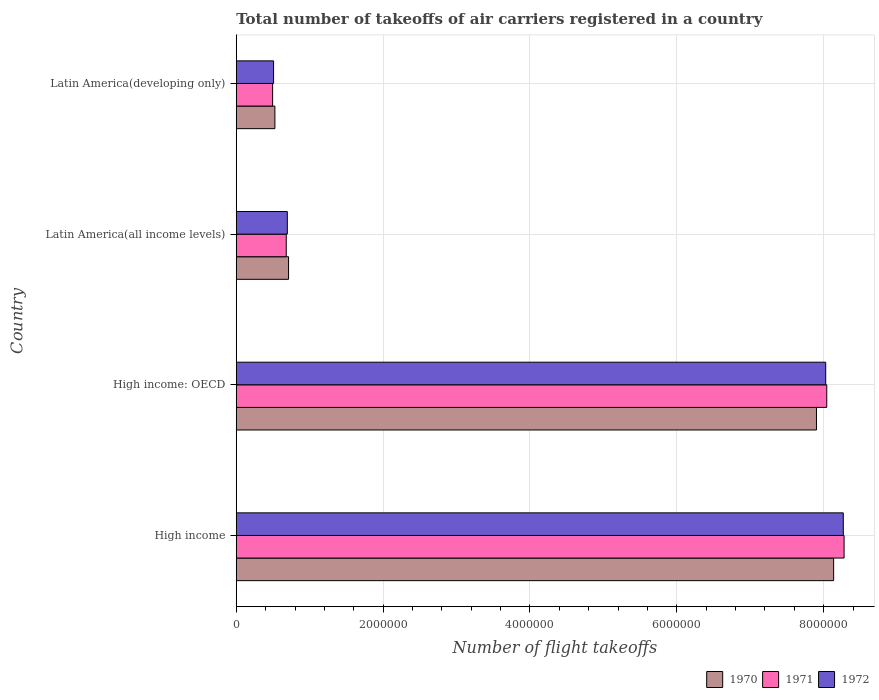How many different coloured bars are there?
Ensure brevity in your answer.  3. How many groups of bars are there?
Your response must be concise. 4. Are the number of bars per tick equal to the number of legend labels?
Provide a short and direct response. Yes. How many bars are there on the 1st tick from the top?
Give a very brief answer. 3. How many bars are there on the 1st tick from the bottom?
Offer a terse response. 3. What is the label of the 4th group of bars from the top?
Your response must be concise. High income. What is the total number of flight takeoffs in 1970 in Latin America(developing only)?
Your answer should be very brief. 5.26e+05. Across all countries, what is the maximum total number of flight takeoffs in 1971?
Offer a very short reply. 8.28e+06. Across all countries, what is the minimum total number of flight takeoffs in 1972?
Offer a very short reply. 5.08e+05. In which country was the total number of flight takeoffs in 1971 minimum?
Give a very brief answer. Latin America(developing only). What is the total total number of flight takeoffs in 1972 in the graph?
Provide a succinct answer. 1.75e+07. What is the difference between the total number of flight takeoffs in 1971 in High income and that in Latin America(all income levels)?
Give a very brief answer. 7.60e+06. What is the difference between the total number of flight takeoffs in 1970 in High income: OECD and the total number of flight takeoffs in 1971 in Latin America(all income levels)?
Make the answer very short. 7.22e+06. What is the average total number of flight takeoffs in 1972 per country?
Offer a terse response. 4.37e+06. What is the difference between the total number of flight takeoffs in 1972 and total number of flight takeoffs in 1970 in Latin America(developing only)?
Provide a succinct answer. -1.79e+04. In how many countries, is the total number of flight takeoffs in 1971 greater than 4800000 ?
Provide a short and direct response. 2. What is the ratio of the total number of flight takeoffs in 1970 in High income to that in Latin America(developing only)?
Provide a succinct answer. 15.46. What is the difference between the highest and the second highest total number of flight takeoffs in 1970?
Make the answer very short. 2.34e+05. What is the difference between the highest and the lowest total number of flight takeoffs in 1970?
Give a very brief answer. 7.61e+06. In how many countries, is the total number of flight takeoffs in 1972 greater than the average total number of flight takeoffs in 1972 taken over all countries?
Make the answer very short. 2. Is the sum of the total number of flight takeoffs in 1972 in High income and Latin America(developing only) greater than the maximum total number of flight takeoffs in 1970 across all countries?
Your answer should be very brief. Yes. What does the 3rd bar from the bottom in Latin America(all income levels) represents?
Provide a succinct answer. 1972. Is it the case that in every country, the sum of the total number of flight takeoffs in 1972 and total number of flight takeoffs in 1970 is greater than the total number of flight takeoffs in 1971?
Your answer should be compact. Yes. How many bars are there?
Keep it short and to the point. 12. What is the difference between two consecutive major ticks on the X-axis?
Keep it short and to the point. 2.00e+06. Are the values on the major ticks of X-axis written in scientific E-notation?
Your answer should be compact. No. Does the graph contain any zero values?
Your answer should be compact. No. Does the graph contain grids?
Provide a succinct answer. Yes. How are the legend labels stacked?
Offer a terse response. Horizontal. What is the title of the graph?
Your answer should be very brief. Total number of takeoffs of air carriers registered in a country. Does "2007" appear as one of the legend labels in the graph?
Give a very brief answer. No. What is the label or title of the X-axis?
Your answer should be very brief. Number of flight takeoffs. What is the label or title of the Y-axis?
Offer a terse response. Country. What is the Number of flight takeoffs in 1970 in High income?
Provide a succinct answer. 8.14e+06. What is the Number of flight takeoffs in 1971 in High income?
Keep it short and to the point. 8.28e+06. What is the Number of flight takeoffs of 1972 in High income?
Your answer should be very brief. 8.27e+06. What is the Number of flight takeoffs in 1970 in High income: OECD?
Your answer should be compact. 7.90e+06. What is the Number of flight takeoffs of 1971 in High income: OECD?
Your answer should be very brief. 8.04e+06. What is the Number of flight takeoffs in 1972 in High income: OECD?
Provide a short and direct response. 8.03e+06. What is the Number of flight takeoffs of 1970 in Latin America(all income levels)?
Provide a short and direct response. 7.12e+05. What is the Number of flight takeoffs in 1971 in Latin America(all income levels)?
Make the answer very short. 6.81e+05. What is the Number of flight takeoffs in 1972 in Latin America(all income levels)?
Provide a succinct answer. 6.96e+05. What is the Number of flight takeoffs in 1970 in Latin America(developing only)?
Keep it short and to the point. 5.26e+05. What is the Number of flight takeoffs in 1971 in Latin America(developing only)?
Provide a short and direct response. 4.95e+05. What is the Number of flight takeoffs of 1972 in Latin America(developing only)?
Provide a short and direct response. 5.08e+05. Across all countries, what is the maximum Number of flight takeoffs of 1970?
Provide a short and direct response. 8.14e+06. Across all countries, what is the maximum Number of flight takeoffs of 1971?
Your answer should be very brief. 8.28e+06. Across all countries, what is the maximum Number of flight takeoffs in 1972?
Offer a terse response. 8.27e+06. Across all countries, what is the minimum Number of flight takeoffs of 1970?
Keep it short and to the point. 5.26e+05. Across all countries, what is the minimum Number of flight takeoffs of 1971?
Ensure brevity in your answer.  4.95e+05. Across all countries, what is the minimum Number of flight takeoffs of 1972?
Offer a terse response. 5.08e+05. What is the total Number of flight takeoffs of 1970 in the graph?
Ensure brevity in your answer.  1.73e+07. What is the total Number of flight takeoffs in 1971 in the graph?
Offer a terse response. 1.75e+07. What is the total Number of flight takeoffs in 1972 in the graph?
Give a very brief answer. 1.75e+07. What is the difference between the Number of flight takeoffs of 1970 in High income and that in High income: OECD?
Your answer should be very brief. 2.34e+05. What is the difference between the Number of flight takeoffs in 1971 in High income and that in High income: OECD?
Keep it short and to the point. 2.36e+05. What is the difference between the Number of flight takeoffs of 1972 in High income and that in High income: OECD?
Provide a short and direct response. 2.40e+05. What is the difference between the Number of flight takeoffs in 1970 in High income and that in Latin America(all income levels)?
Ensure brevity in your answer.  7.42e+06. What is the difference between the Number of flight takeoffs of 1971 in High income and that in Latin America(all income levels)?
Provide a short and direct response. 7.60e+06. What is the difference between the Number of flight takeoffs of 1972 in High income and that in Latin America(all income levels)?
Make the answer very short. 7.57e+06. What is the difference between the Number of flight takeoffs of 1970 in High income and that in Latin America(developing only)?
Make the answer very short. 7.61e+06. What is the difference between the Number of flight takeoffs in 1971 in High income and that in Latin America(developing only)?
Keep it short and to the point. 7.78e+06. What is the difference between the Number of flight takeoffs of 1972 in High income and that in Latin America(developing only)?
Keep it short and to the point. 7.76e+06. What is the difference between the Number of flight takeoffs of 1970 in High income: OECD and that in Latin America(all income levels)?
Offer a very short reply. 7.19e+06. What is the difference between the Number of flight takeoffs of 1971 in High income: OECD and that in Latin America(all income levels)?
Offer a very short reply. 7.36e+06. What is the difference between the Number of flight takeoffs in 1972 in High income: OECD and that in Latin America(all income levels)?
Keep it short and to the point. 7.33e+06. What is the difference between the Number of flight takeoffs of 1970 in High income: OECD and that in Latin America(developing only)?
Offer a very short reply. 7.38e+06. What is the difference between the Number of flight takeoffs in 1971 in High income: OECD and that in Latin America(developing only)?
Provide a succinct answer. 7.55e+06. What is the difference between the Number of flight takeoffs of 1972 in High income: OECD and that in Latin America(developing only)?
Offer a terse response. 7.52e+06. What is the difference between the Number of flight takeoffs of 1970 in Latin America(all income levels) and that in Latin America(developing only)?
Offer a terse response. 1.86e+05. What is the difference between the Number of flight takeoffs of 1971 in Latin America(all income levels) and that in Latin America(developing only)?
Offer a terse response. 1.86e+05. What is the difference between the Number of flight takeoffs in 1972 in Latin America(all income levels) and that in Latin America(developing only)?
Give a very brief answer. 1.87e+05. What is the difference between the Number of flight takeoffs of 1970 in High income and the Number of flight takeoffs of 1971 in High income: OECD?
Offer a terse response. 9.37e+04. What is the difference between the Number of flight takeoffs of 1970 in High income and the Number of flight takeoffs of 1972 in High income: OECD?
Provide a succinct answer. 1.08e+05. What is the difference between the Number of flight takeoffs in 1971 in High income and the Number of flight takeoffs in 1972 in High income: OECD?
Give a very brief answer. 2.50e+05. What is the difference between the Number of flight takeoffs of 1970 in High income and the Number of flight takeoffs of 1971 in Latin America(all income levels)?
Your answer should be very brief. 7.46e+06. What is the difference between the Number of flight takeoffs of 1970 in High income and the Number of flight takeoffs of 1972 in Latin America(all income levels)?
Provide a short and direct response. 7.44e+06. What is the difference between the Number of flight takeoffs of 1971 in High income and the Number of flight takeoffs of 1972 in Latin America(all income levels)?
Provide a short and direct response. 7.58e+06. What is the difference between the Number of flight takeoffs of 1970 in High income and the Number of flight takeoffs of 1971 in Latin America(developing only)?
Offer a terse response. 7.64e+06. What is the difference between the Number of flight takeoffs in 1970 in High income and the Number of flight takeoffs in 1972 in Latin America(developing only)?
Make the answer very short. 7.63e+06. What is the difference between the Number of flight takeoffs of 1971 in High income and the Number of flight takeoffs of 1972 in Latin America(developing only)?
Give a very brief answer. 7.77e+06. What is the difference between the Number of flight takeoffs in 1970 in High income: OECD and the Number of flight takeoffs in 1971 in Latin America(all income levels)?
Keep it short and to the point. 7.22e+06. What is the difference between the Number of flight takeoffs of 1970 in High income: OECD and the Number of flight takeoffs of 1972 in Latin America(all income levels)?
Your response must be concise. 7.21e+06. What is the difference between the Number of flight takeoffs in 1971 in High income: OECD and the Number of flight takeoffs in 1972 in Latin America(all income levels)?
Give a very brief answer. 7.35e+06. What is the difference between the Number of flight takeoffs in 1970 in High income: OECD and the Number of flight takeoffs in 1971 in Latin America(developing only)?
Your response must be concise. 7.41e+06. What is the difference between the Number of flight takeoffs in 1970 in High income: OECD and the Number of flight takeoffs in 1972 in Latin America(developing only)?
Your response must be concise. 7.39e+06. What is the difference between the Number of flight takeoffs of 1971 in High income: OECD and the Number of flight takeoffs of 1972 in Latin America(developing only)?
Offer a very short reply. 7.53e+06. What is the difference between the Number of flight takeoffs of 1970 in Latin America(all income levels) and the Number of flight takeoffs of 1971 in Latin America(developing only)?
Offer a terse response. 2.17e+05. What is the difference between the Number of flight takeoffs of 1970 in Latin America(all income levels) and the Number of flight takeoffs of 1972 in Latin America(developing only)?
Provide a short and direct response. 2.04e+05. What is the difference between the Number of flight takeoffs of 1971 in Latin America(all income levels) and the Number of flight takeoffs of 1972 in Latin America(developing only)?
Your answer should be very brief. 1.73e+05. What is the average Number of flight takeoffs of 1970 per country?
Ensure brevity in your answer.  4.32e+06. What is the average Number of flight takeoffs of 1971 per country?
Give a very brief answer. 4.37e+06. What is the average Number of flight takeoffs in 1972 per country?
Your answer should be very brief. 4.37e+06. What is the difference between the Number of flight takeoffs of 1970 and Number of flight takeoffs of 1971 in High income?
Your answer should be compact. -1.42e+05. What is the difference between the Number of flight takeoffs of 1970 and Number of flight takeoffs of 1972 in High income?
Offer a terse response. -1.32e+05. What is the difference between the Number of flight takeoffs of 1971 and Number of flight takeoffs of 1972 in High income?
Offer a very short reply. 1.09e+04. What is the difference between the Number of flight takeoffs in 1970 and Number of flight takeoffs in 1971 in High income: OECD?
Your answer should be very brief. -1.40e+05. What is the difference between the Number of flight takeoffs of 1970 and Number of flight takeoffs of 1972 in High income: OECD?
Keep it short and to the point. -1.26e+05. What is the difference between the Number of flight takeoffs in 1971 and Number of flight takeoffs in 1972 in High income: OECD?
Offer a terse response. 1.43e+04. What is the difference between the Number of flight takeoffs in 1970 and Number of flight takeoffs in 1971 in Latin America(all income levels)?
Your answer should be compact. 3.13e+04. What is the difference between the Number of flight takeoffs in 1970 and Number of flight takeoffs in 1972 in Latin America(all income levels)?
Offer a very short reply. 1.68e+04. What is the difference between the Number of flight takeoffs of 1971 and Number of flight takeoffs of 1972 in Latin America(all income levels)?
Keep it short and to the point. -1.45e+04. What is the difference between the Number of flight takeoffs in 1970 and Number of flight takeoffs in 1971 in Latin America(developing only)?
Offer a very short reply. 3.09e+04. What is the difference between the Number of flight takeoffs of 1970 and Number of flight takeoffs of 1972 in Latin America(developing only)?
Ensure brevity in your answer.  1.79e+04. What is the difference between the Number of flight takeoffs in 1971 and Number of flight takeoffs in 1972 in Latin America(developing only)?
Provide a succinct answer. -1.30e+04. What is the ratio of the Number of flight takeoffs of 1970 in High income to that in High income: OECD?
Offer a very short reply. 1.03. What is the ratio of the Number of flight takeoffs in 1971 in High income to that in High income: OECD?
Offer a terse response. 1.03. What is the ratio of the Number of flight takeoffs of 1972 in High income to that in High income: OECD?
Give a very brief answer. 1.03. What is the ratio of the Number of flight takeoffs of 1970 in High income to that in Latin America(all income levels)?
Make the answer very short. 11.42. What is the ratio of the Number of flight takeoffs in 1971 in High income to that in Latin America(all income levels)?
Offer a terse response. 12.16. What is the ratio of the Number of flight takeoffs in 1972 in High income to that in Latin America(all income levels)?
Ensure brevity in your answer.  11.89. What is the ratio of the Number of flight takeoffs in 1970 in High income to that in Latin America(developing only)?
Offer a terse response. 15.46. What is the ratio of the Number of flight takeoffs of 1971 in High income to that in Latin America(developing only)?
Make the answer very short. 16.71. What is the ratio of the Number of flight takeoffs in 1972 in High income to that in Latin America(developing only)?
Your response must be concise. 16.26. What is the ratio of the Number of flight takeoffs in 1970 in High income: OECD to that in Latin America(all income levels)?
Provide a short and direct response. 11.09. What is the ratio of the Number of flight takeoffs of 1971 in High income: OECD to that in Latin America(all income levels)?
Provide a succinct answer. 11.81. What is the ratio of the Number of flight takeoffs in 1972 in High income: OECD to that in Latin America(all income levels)?
Your answer should be compact. 11.54. What is the ratio of the Number of flight takeoffs in 1970 in High income: OECD to that in Latin America(developing only)?
Provide a succinct answer. 15.01. What is the ratio of the Number of flight takeoffs in 1971 in High income: OECD to that in Latin America(developing only)?
Your answer should be compact. 16.23. What is the ratio of the Number of flight takeoffs in 1972 in High income: OECD to that in Latin America(developing only)?
Ensure brevity in your answer.  15.79. What is the ratio of the Number of flight takeoffs of 1970 in Latin America(all income levels) to that in Latin America(developing only)?
Give a very brief answer. 1.35. What is the ratio of the Number of flight takeoffs of 1971 in Latin America(all income levels) to that in Latin America(developing only)?
Make the answer very short. 1.37. What is the ratio of the Number of flight takeoffs in 1972 in Latin America(all income levels) to that in Latin America(developing only)?
Offer a terse response. 1.37. What is the difference between the highest and the second highest Number of flight takeoffs of 1970?
Ensure brevity in your answer.  2.34e+05. What is the difference between the highest and the second highest Number of flight takeoffs in 1971?
Provide a succinct answer. 2.36e+05. What is the difference between the highest and the second highest Number of flight takeoffs of 1972?
Ensure brevity in your answer.  2.40e+05. What is the difference between the highest and the lowest Number of flight takeoffs in 1970?
Provide a succinct answer. 7.61e+06. What is the difference between the highest and the lowest Number of flight takeoffs of 1971?
Offer a very short reply. 7.78e+06. What is the difference between the highest and the lowest Number of flight takeoffs of 1972?
Give a very brief answer. 7.76e+06. 